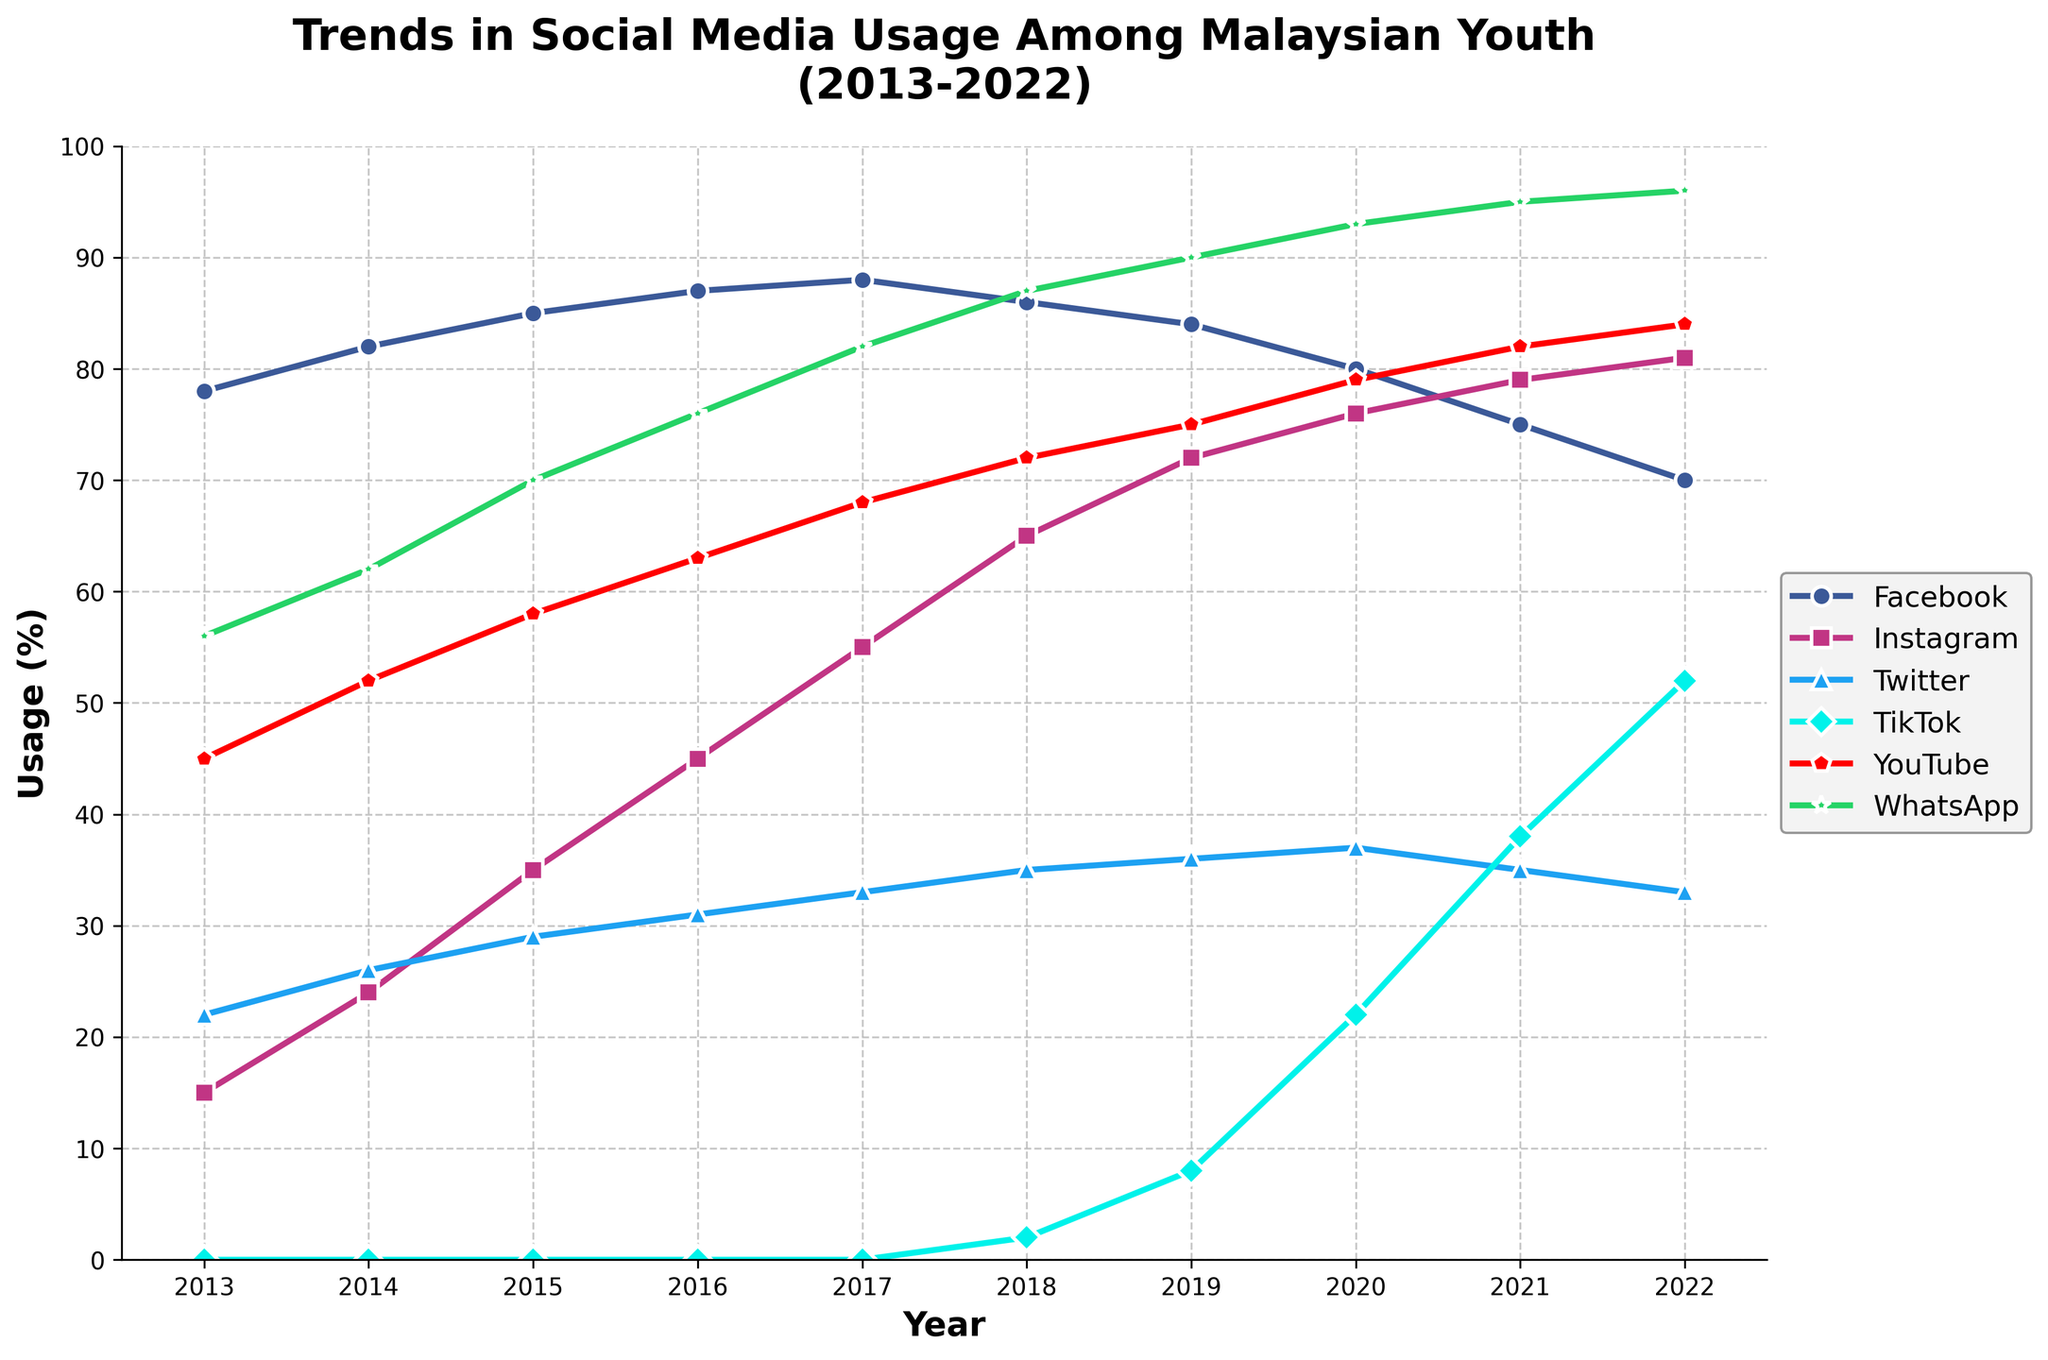What is the overall trend in Facebook usage from 2013 to 2022? Facebook usage starts high at 78% in 2013, increases to a peak of 88% in 2017, and then steadily decreases to 70% by 2022.
Answer: A peak in 2017, then a steady decline Which platform showed the most growth between 2018 and 2022? TikTok usage grew from 2% in 2018 to 52% in 2022, showing the most significant increase among all platforms.
Answer: TikTok Compare the usage of Instagram and Twitter in 2022. Which one was higher, and by how much? Instagram usage was 81%, and Twitter usage was 33%. The difference is 81% - 33% = 48%.
Answer: Instagram by 48% In which year did WhatsApp usage reach above 90% for the first time? WhatsApp usage reached 93% in 2020, which is above 90% for the first time.
Answer: 2020 How did YouTube usage change from 2013 to 2019? YouTube usage increased from 45% in 2013 to 75% in 2019, showing a steady upward trend.
Answer: Increased steadily Calculate the average usage of Spotify across all years. The total of all yearly usages for Spotify (15 + 24 + 35 + 45 + 55 + 65 + 72 + 76 + 79 + 81) is 547. Average = 547 / 10 ≈ 54.7%
Answer: 54.7% Between Facebook and Instagram, which platform had a higher peak usage, and what was the percentage? Facebook had a peak usage of 88% in 2017, while Instagram had a peak usage of 81% in 2022. Thus, Facebook had a higher peak usage.
Answer: Facebook, 88% Which platform showed the least change in usage from 2013 to 2022? Twitter usage went from 22% in 2013 to 33% in 2022, a change of 11 percentage points, which is comparatively small.
Answer: Twitter Compare the trend in TikTok usage from its introduction to the last recorded year. TikTok usage started at 0 in 2013 and increased to 52% in 2022, showing a rapid growth rate, especially after 2018.
Answer: Rapid growth after 2018 In which year did Instagram overtake Facebook in terms of usage? Instagram usage climbed higher than Facebook in 2022, with Instagram at 81% and Facebook at 70%.
Answer: 2022 